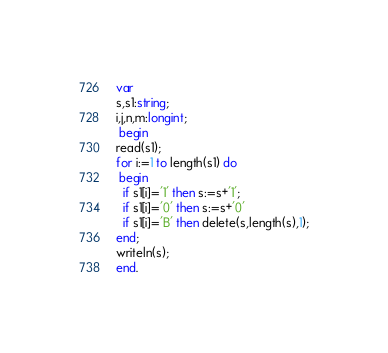<code> <loc_0><loc_0><loc_500><loc_500><_Pascal_>var
s,s1:string;
i,j,n,m:longint;
 begin
read(s1);
for i:=1 to length(s1) do
 begin
  if s1[i]='1' then s:=s+'1';
  if s1[i]='0' then s:=s+'0'
  if s1[i]='B' then delete(s,length(s),1);
end;
writeln(s);
end.</code> 